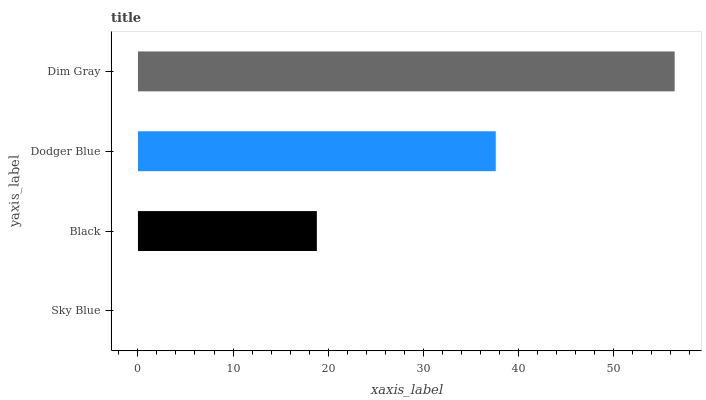Is Sky Blue the minimum?
Answer yes or no. Yes. Is Dim Gray the maximum?
Answer yes or no. Yes. Is Black the minimum?
Answer yes or no. No. Is Black the maximum?
Answer yes or no. No. Is Black greater than Sky Blue?
Answer yes or no. Yes. Is Sky Blue less than Black?
Answer yes or no. Yes. Is Sky Blue greater than Black?
Answer yes or no. No. Is Black less than Sky Blue?
Answer yes or no. No. Is Dodger Blue the high median?
Answer yes or no. Yes. Is Black the low median?
Answer yes or no. Yes. Is Sky Blue the high median?
Answer yes or no. No. Is Sky Blue the low median?
Answer yes or no. No. 